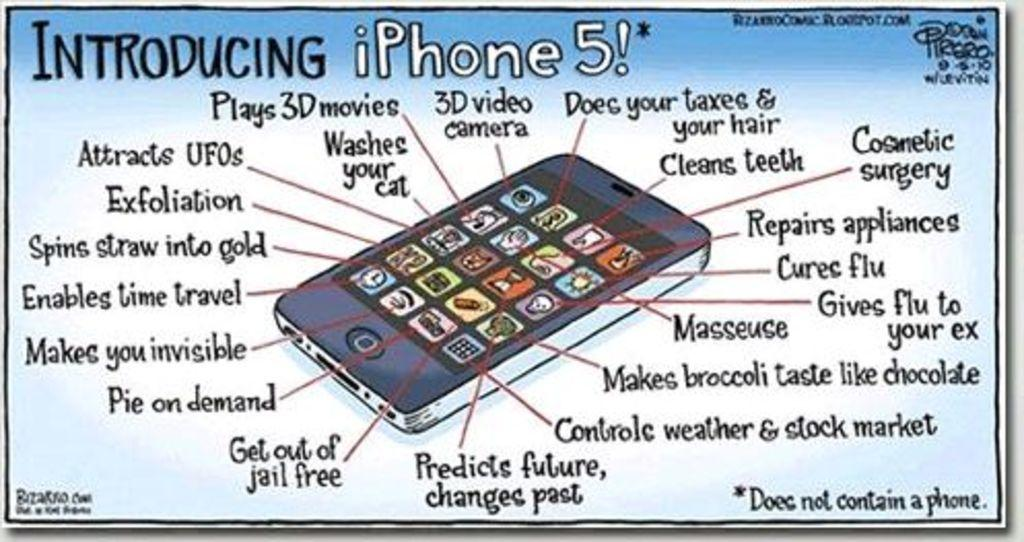<image>
Relay a brief, clear account of the picture shown. A cartoon about the iPhone 5 and all its "features." 